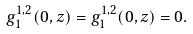Convert formula to latex. <formula><loc_0><loc_0><loc_500><loc_500>g _ { 1 } ^ { 1 , 2 } ( 0 , z ) = g _ { 1 } ^ { 1 , 2 } ( 0 , z ) = 0 .</formula> 